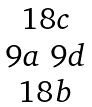<formula> <loc_0><loc_0><loc_500><loc_500>\begin{matrix} 1 8 c \\ 9 a \ 9 d \\ 1 8 b \end{matrix}</formula> 